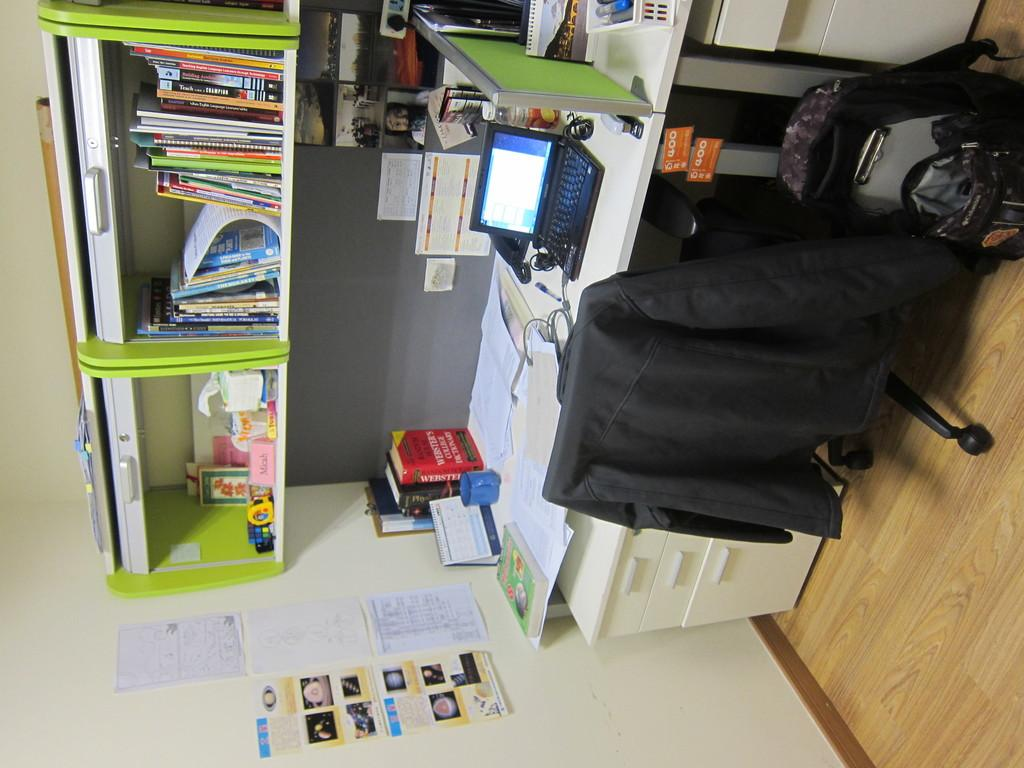<image>
Describe the image concisely. A Webster's dictionary is one of the books standing in a corner of a desk. 